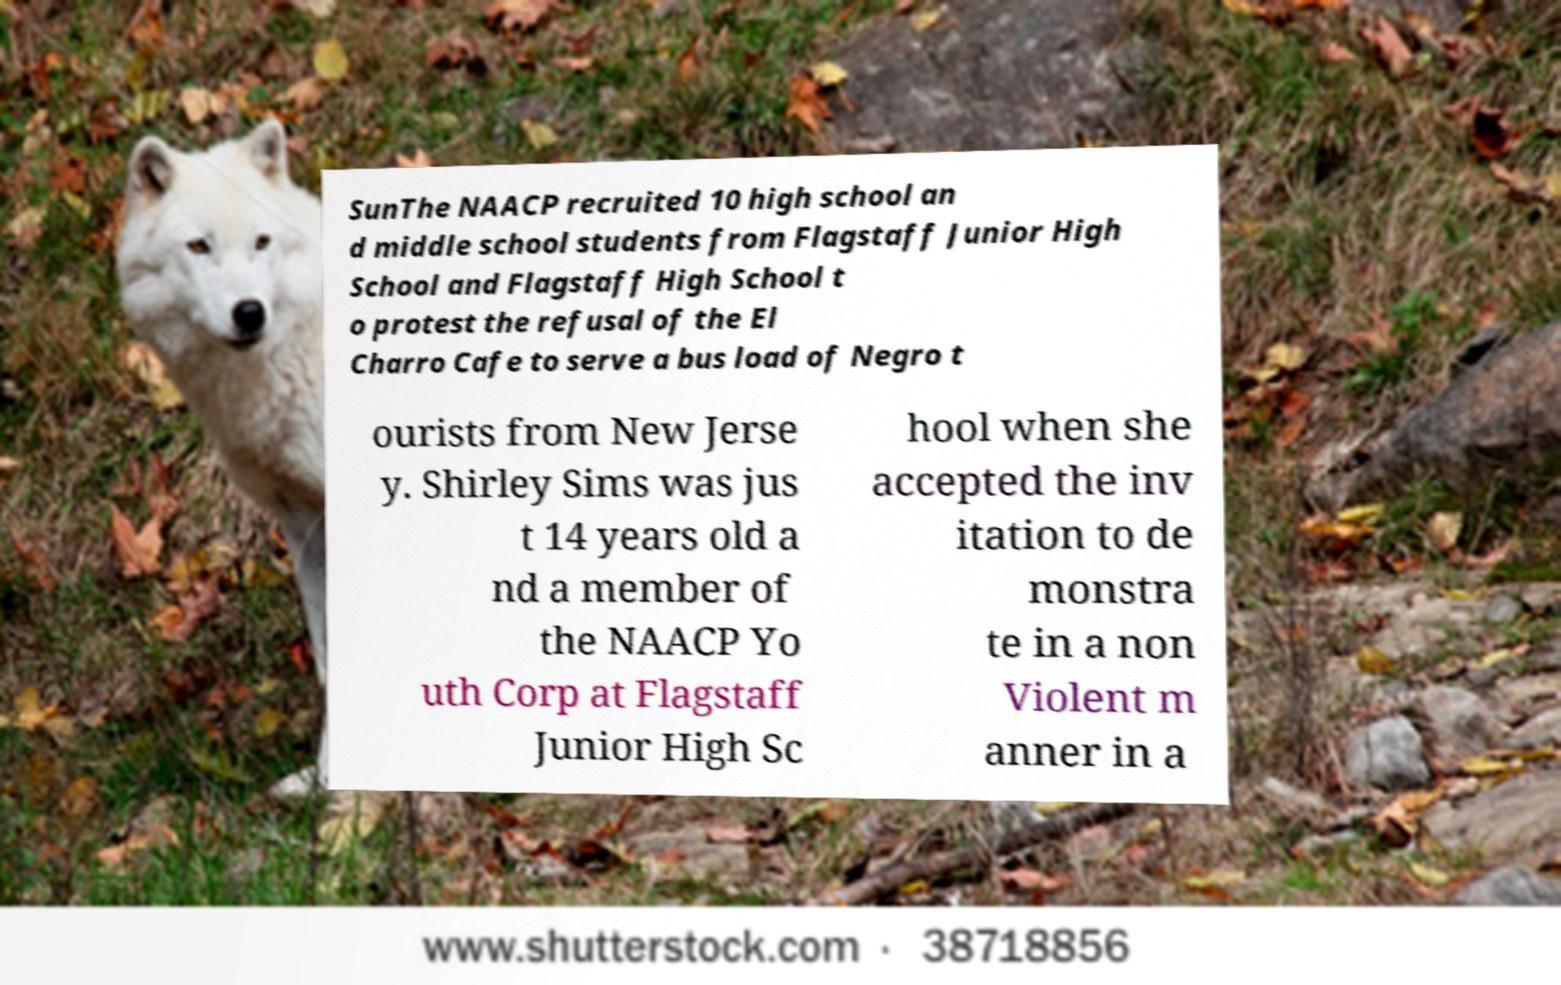There's text embedded in this image that I need extracted. Can you transcribe it verbatim? SunThe NAACP recruited 10 high school an d middle school students from Flagstaff Junior High School and Flagstaff High School t o protest the refusal of the El Charro Cafe to serve a bus load of Negro t ourists from New Jerse y. Shirley Sims was jus t 14 years old a nd a member of the NAACP Yo uth Corp at Flagstaff Junior High Sc hool when she accepted the inv itation to de monstra te in a non Violent m anner in a 